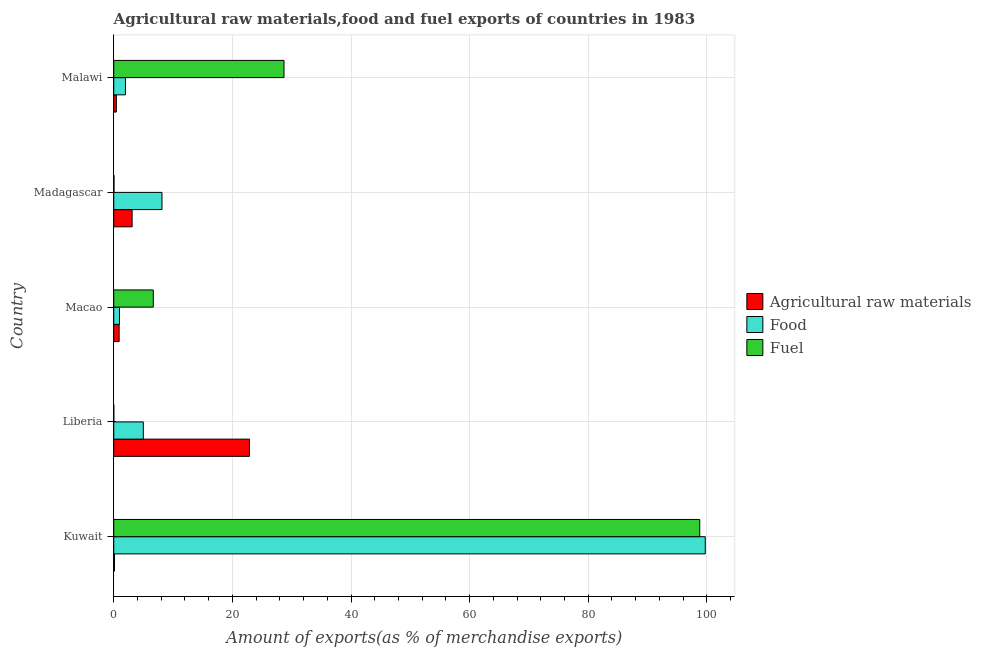How many different coloured bars are there?
Provide a succinct answer. 3. Are the number of bars on each tick of the Y-axis equal?
Offer a very short reply. Yes. What is the label of the 1st group of bars from the top?
Provide a short and direct response. Malawi. In how many cases, is the number of bars for a given country not equal to the number of legend labels?
Your answer should be compact. 0. What is the percentage of fuel exports in Kuwait?
Your response must be concise. 98.8. Across all countries, what is the maximum percentage of food exports?
Keep it short and to the point. 99.73. Across all countries, what is the minimum percentage of food exports?
Ensure brevity in your answer.  0.96. In which country was the percentage of raw materials exports maximum?
Make the answer very short. Liberia. In which country was the percentage of raw materials exports minimum?
Make the answer very short. Kuwait. What is the total percentage of fuel exports in the graph?
Provide a succinct answer. 134.22. What is the difference between the percentage of fuel exports in Madagascar and that in Malawi?
Make the answer very short. -28.67. What is the difference between the percentage of fuel exports in Macao and the percentage of food exports in Malawi?
Your answer should be very brief. 4.69. What is the average percentage of fuel exports per country?
Provide a short and direct response. 26.84. What is the difference between the percentage of food exports and percentage of raw materials exports in Madagascar?
Offer a very short reply. 5.03. What is the ratio of the percentage of food exports in Macao to that in Madagascar?
Give a very brief answer. 0.12. Is the percentage of food exports in Kuwait less than that in Malawi?
Provide a succinct answer. No. What is the difference between the highest and the second highest percentage of fuel exports?
Make the answer very short. 70.09. What is the difference between the highest and the lowest percentage of food exports?
Provide a succinct answer. 98.76. Is the sum of the percentage of food exports in Kuwait and Malawi greater than the maximum percentage of raw materials exports across all countries?
Provide a short and direct response. Yes. What does the 2nd bar from the top in Kuwait represents?
Keep it short and to the point. Food. What does the 2nd bar from the bottom in Madagascar represents?
Your answer should be very brief. Food. Is it the case that in every country, the sum of the percentage of raw materials exports and percentage of food exports is greater than the percentage of fuel exports?
Your answer should be very brief. No. How many bars are there?
Make the answer very short. 15. What is the difference between two consecutive major ticks on the X-axis?
Make the answer very short. 20. Does the graph contain grids?
Your response must be concise. Yes. Where does the legend appear in the graph?
Make the answer very short. Center right. How many legend labels are there?
Ensure brevity in your answer.  3. How are the legend labels stacked?
Your answer should be very brief. Vertical. What is the title of the graph?
Ensure brevity in your answer.  Agricultural raw materials,food and fuel exports of countries in 1983. Does "Tertiary education" appear as one of the legend labels in the graph?
Your answer should be very brief. No. What is the label or title of the X-axis?
Offer a terse response. Amount of exports(as % of merchandise exports). What is the label or title of the Y-axis?
Make the answer very short. Country. What is the Amount of exports(as % of merchandise exports) in Agricultural raw materials in Kuwait?
Provide a succinct answer. 0.13. What is the Amount of exports(as % of merchandise exports) in Food in Kuwait?
Provide a succinct answer. 99.73. What is the Amount of exports(as % of merchandise exports) in Fuel in Kuwait?
Make the answer very short. 98.8. What is the Amount of exports(as % of merchandise exports) in Agricultural raw materials in Liberia?
Make the answer very short. 22.88. What is the Amount of exports(as % of merchandise exports) in Food in Liberia?
Offer a very short reply. 4.99. What is the Amount of exports(as % of merchandise exports) in Fuel in Liberia?
Ensure brevity in your answer.  0.01. What is the Amount of exports(as % of merchandise exports) of Agricultural raw materials in Macao?
Keep it short and to the point. 0.91. What is the Amount of exports(as % of merchandise exports) of Food in Macao?
Provide a short and direct response. 0.96. What is the Amount of exports(as % of merchandise exports) in Fuel in Macao?
Make the answer very short. 6.67. What is the Amount of exports(as % of merchandise exports) of Agricultural raw materials in Madagascar?
Your answer should be very brief. 3.1. What is the Amount of exports(as % of merchandise exports) in Food in Madagascar?
Offer a very short reply. 8.13. What is the Amount of exports(as % of merchandise exports) in Fuel in Madagascar?
Your answer should be very brief. 0.04. What is the Amount of exports(as % of merchandise exports) in Agricultural raw materials in Malawi?
Your answer should be compact. 0.44. What is the Amount of exports(as % of merchandise exports) of Food in Malawi?
Make the answer very short. 1.97. What is the Amount of exports(as % of merchandise exports) in Fuel in Malawi?
Keep it short and to the point. 28.71. Across all countries, what is the maximum Amount of exports(as % of merchandise exports) in Agricultural raw materials?
Your answer should be very brief. 22.88. Across all countries, what is the maximum Amount of exports(as % of merchandise exports) in Food?
Provide a short and direct response. 99.73. Across all countries, what is the maximum Amount of exports(as % of merchandise exports) of Fuel?
Your answer should be very brief. 98.8. Across all countries, what is the minimum Amount of exports(as % of merchandise exports) in Agricultural raw materials?
Give a very brief answer. 0.13. Across all countries, what is the minimum Amount of exports(as % of merchandise exports) of Food?
Ensure brevity in your answer.  0.96. Across all countries, what is the minimum Amount of exports(as % of merchandise exports) in Fuel?
Your answer should be compact. 0.01. What is the total Amount of exports(as % of merchandise exports) in Agricultural raw materials in the graph?
Offer a very short reply. 27.45. What is the total Amount of exports(as % of merchandise exports) in Food in the graph?
Ensure brevity in your answer.  115.79. What is the total Amount of exports(as % of merchandise exports) of Fuel in the graph?
Offer a terse response. 134.22. What is the difference between the Amount of exports(as % of merchandise exports) in Agricultural raw materials in Kuwait and that in Liberia?
Your answer should be very brief. -22.75. What is the difference between the Amount of exports(as % of merchandise exports) in Food in Kuwait and that in Liberia?
Your response must be concise. 94.74. What is the difference between the Amount of exports(as % of merchandise exports) in Fuel in Kuwait and that in Liberia?
Provide a short and direct response. 98.79. What is the difference between the Amount of exports(as % of merchandise exports) in Agricultural raw materials in Kuwait and that in Macao?
Provide a short and direct response. -0.78. What is the difference between the Amount of exports(as % of merchandise exports) in Food in Kuwait and that in Macao?
Your answer should be compact. 98.76. What is the difference between the Amount of exports(as % of merchandise exports) in Fuel in Kuwait and that in Macao?
Offer a terse response. 92.13. What is the difference between the Amount of exports(as % of merchandise exports) in Agricultural raw materials in Kuwait and that in Madagascar?
Your response must be concise. -2.97. What is the difference between the Amount of exports(as % of merchandise exports) of Food in Kuwait and that in Madagascar?
Provide a succinct answer. 91.59. What is the difference between the Amount of exports(as % of merchandise exports) of Fuel in Kuwait and that in Madagascar?
Your answer should be very brief. 98.76. What is the difference between the Amount of exports(as % of merchandise exports) of Agricultural raw materials in Kuwait and that in Malawi?
Your answer should be compact. -0.32. What is the difference between the Amount of exports(as % of merchandise exports) of Food in Kuwait and that in Malawi?
Offer a terse response. 97.75. What is the difference between the Amount of exports(as % of merchandise exports) in Fuel in Kuwait and that in Malawi?
Your answer should be compact. 70.09. What is the difference between the Amount of exports(as % of merchandise exports) of Agricultural raw materials in Liberia and that in Macao?
Provide a short and direct response. 21.97. What is the difference between the Amount of exports(as % of merchandise exports) of Food in Liberia and that in Macao?
Provide a succinct answer. 4.02. What is the difference between the Amount of exports(as % of merchandise exports) of Fuel in Liberia and that in Macao?
Provide a short and direct response. -6.66. What is the difference between the Amount of exports(as % of merchandise exports) in Agricultural raw materials in Liberia and that in Madagascar?
Give a very brief answer. 19.78. What is the difference between the Amount of exports(as % of merchandise exports) of Food in Liberia and that in Madagascar?
Keep it short and to the point. -3.14. What is the difference between the Amount of exports(as % of merchandise exports) of Fuel in Liberia and that in Madagascar?
Your answer should be compact. -0.03. What is the difference between the Amount of exports(as % of merchandise exports) of Agricultural raw materials in Liberia and that in Malawi?
Provide a short and direct response. 22.44. What is the difference between the Amount of exports(as % of merchandise exports) in Food in Liberia and that in Malawi?
Provide a short and direct response. 3.01. What is the difference between the Amount of exports(as % of merchandise exports) in Fuel in Liberia and that in Malawi?
Your response must be concise. -28.7. What is the difference between the Amount of exports(as % of merchandise exports) of Agricultural raw materials in Macao and that in Madagascar?
Keep it short and to the point. -2.19. What is the difference between the Amount of exports(as % of merchandise exports) in Food in Macao and that in Madagascar?
Give a very brief answer. -7.17. What is the difference between the Amount of exports(as % of merchandise exports) in Fuel in Macao and that in Madagascar?
Your answer should be compact. 6.63. What is the difference between the Amount of exports(as % of merchandise exports) of Agricultural raw materials in Macao and that in Malawi?
Provide a short and direct response. 0.47. What is the difference between the Amount of exports(as % of merchandise exports) in Food in Macao and that in Malawi?
Offer a very short reply. -1.01. What is the difference between the Amount of exports(as % of merchandise exports) of Fuel in Macao and that in Malawi?
Ensure brevity in your answer.  -22.04. What is the difference between the Amount of exports(as % of merchandise exports) in Agricultural raw materials in Madagascar and that in Malawi?
Offer a terse response. 2.66. What is the difference between the Amount of exports(as % of merchandise exports) in Food in Madagascar and that in Malawi?
Your answer should be compact. 6.16. What is the difference between the Amount of exports(as % of merchandise exports) in Fuel in Madagascar and that in Malawi?
Your answer should be compact. -28.67. What is the difference between the Amount of exports(as % of merchandise exports) in Agricultural raw materials in Kuwait and the Amount of exports(as % of merchandise exports) in Food in Liberia?
Provide a short and direct response. -4.86. What is the difference between the Amount of exports(as % of merchandise exports) of Agricultural raw materials in Kuwait and the Amount of exports(as % of merchandise exports) of Fuel in Liberia?
Ensure brevity in your answer.  0.12. What is the difference between the Amount of exports(as % of merchandise exports) in Food in Kuwait and the Amount of exports(as % of merchandise exports) in Fuel in Liberia?
Offer a terse response. 99.72. What is the difference between the Amount of exports(as % of merchandise exports) in Agricultural raw materials in Kuwait and the Amount of exports(as % of merchandise exports) in Food in Macao?
Provide a short and direct response. -0.84. What is the difference between the Amount of exports(as % of merchandise exports) in Agricultural raw materials in Kuwait and the Amount of exports(as % of merchandise exports) in Fuel in Macao?
Give a very brief answer. -6.54. What is the difference between the Amount of exports(as % of merchandise exports) in Food in Kuwait and the Amount of exports(as % of merchandise exports) in Fuel in Macao?
Provide a succinct answer. 93.06. What is the difference between the Amount of exports(as % of merchandise exports) in Agricultural raw materials in Kuwait and the Amount of exports(as % of merchandise exports) in Food in Madagascar?
Provide a succinct answer. -8.01. What is the difference between the Amount of exports(as % of merchandise exports) of Agricultural raw materials in Kuwait and the Amount of exports(as % of merchandise exports) of Fuel in Madagascar?
Ensure brevity in your answer.  0.09. What is the difference between the Amount of exports(as % of merchandise exports) of Food in Kuwait and the Amount of exports(as % of merchandise exports) of Fuel in Madagascar?
Make the answer very short. 99.69. What is the difference between the Amount of exports(as % of merchandise exports) of Agricultural raw materials in Kuwait and the Amount of exports(as % of merchandise exports) of Food in Malawi?
Your answer should be very brief. -1.85. What is the difference between the Amount of exports(as % of merchandise exports) in Agricultural raw materials in Kuwait and the Amount of exports(as % of merchandise exports) in Fuel in Malawi?
Your answer should be compact. -28.58. What is the difference between the Amount of exports(as % of merchandise exports) of Food in Kuwait and the Amount of exports(as % of merchandise exports) of Fuel in Malawi?
Keep it short and to the point. 71.02. What is the difference between the Amount of exports(as % of merchandise exports) of Agricultural raw materials in Liberia and the Amount of exports(as % of merchandise exports) of Food in Macao?
Provide a succinct answer. 21.91. What is the difference between the Amount of exports(as % of merchandise exports) in Agricultural raw materials in Liberia and the Amount of exports(as % of merchandise exports) in Fuel in Macao?
Offer a terse response. 16.21. What is the difference between the Amount of exports(as % of merchandise exports) of Food in Liberia and the Amount of exports(as % of merchandise exports) of Fuel in Macao?
Give a very brief answer. -1.68. What is the difference between the Amount of exports(as % of merchandise exports) in Agricultural raw materials in Liberia and the Amount of exports(as % of merchandise exports) in Food in Madagascar?
Provide a short and direct response. 14.75. What is the difference between the Amount of exports(as % of merchandise exports) in Agricultural raw materials in Liberia and the Amount of exports(as % of merchandise exports) in Fuel in Madagascar?
Ensure brevity in your answer.  22.84. What is the difference between the Amount of exports(as % of merchandise exports) in Food in Liberia and the Amount of exports(as % of merchandise exports) in Fuel in Madagascar?
Your response must be concise. 4.95. What is the difference between the Amount of exports(as % of merchandise exports) of Agricultural raw materials in Liberia and the Amount of exports(as % of merchandise exports) of Food in Malawi?
Give a very brief answer. 20.9. What is the difference between the Amount of exports(as % of merchandise exports) of Agricultural raw materials in Liberia and the Amount of exports(as % of merchandise exports) of Fuel in Malawi?
Make the answer very short. -5.83. What is the difference between the Amount of exports(as % of merchandise exports) in Food in Liberia and the Amount of exports(as % of merchandise exports) in Fuel in Malawi?
Your answer should be very brief. -23.72. What is the difference between the Amount of exports(as % of merchandise exports) in Agricultural raw materials in Macao and the Amount of exports(as % of merchandise exports) in Food in Madagascar?
Your answer should be compact. -7.22. What is the difference between the Amount of exports(as % of merchandise exports) of Agricultural raw materials in Macao and the Amount of exports(as % of merchandise exports) of Fuel in Madagascar?
Provide a succinct answer. 0.87. What is the difference between the Amount of exports(as % of merchandise exports) in Food in Macao and the Amount of exports(as % of merchandise exports) in Fuel in Madagascar?
Your answer should be compact. 0.92. What is the difference between the Amount of exports(as % of merchandise exports) in Agricultural raw materials in Macao and the Amount of exports(as % of merchandise exports) in Food in Malawi?
Give a very brief answer. -1.07. What is the difference between the Amount of exports(as % of merchandise exports) in Agricultural raw materials in Macao and the Amount of exports(as % of merchandise exports) in Fuel in Malawi?
Your answer should be compact. -27.8. What is the difference between the Amount of exports(as % of merchandise exports) in Food in Macao and the Amount of exports(as % of merchandise exports) in Fuel in Malawi?
Keep it short and to the point. -27.74. What is the difference between the Amount of exports(as % of merchandise exports) in Agricultural raw materials in Madagascar and the Amount of exports(as % of merchandise exports) in Food in Malawi?
Your answer should be compact. 1.12. What is the difference between the Amount of exports(as % of merchandise exports) in Agricultural raw materials in Madagascar and the Amount of exports(as % of merchandise exports) in Fuel in Malawi?
Offer a terse response. -25.61. What is the difference between the Amount of exports(as % of merchandise exports) of Food in Madagascar and the Amount of exports(as % of merchandise exports) of Fuel in Malawi?
Your answer should be very brief. -20.57. What is the average Amount of exports(as % of merchandise exports) of Agricultural raw materials per country?
Your answer should be very brief. 5.49. What is the average Amount of exports(as % of merchandise exports) in Food per country?
Ensure brevity in your answer.  23.16. What is the average Amount of exports(as % of merchandise exports) of Fuel per country?
Give a very brief answer. 26.84. What is the difference between the Amount of exports(as % of merchandise exports) of Agricultural raw materials and Amount of exports(as % of merchandise exports) of Food in Kuwait?
Provide a succinct answer. -99.6. What is the difference between the Amount of exports(as % of merchandise exports) of Agricultural raw materials and Amount of exports(as % of merchandise exports) of Fuel in Kuwait?
Provide a succinct answer. -98.67. What is the difference between the Amount of exports(as % of merchandise exports) in Food and Amount of exports(as % of merchandise exports) in Fuel in Kuwait?
Give a very brief answer. 0.93. What is the difference between the Amount of exports(as % of merchandise exports) of Agricultural raw materials and Amount of exports(as % of merchandise exports) of Food in Liberia?
Your answer should be very brief. 17.89. What is the difference between the Amount of exports(as % of merchandise exports) in Agricultural raw materials and Amount of exports(as % of merchandise exports) in Fuel in Liberia?
Provide a succinct answer. 22.87. What is the difference between the Amount of exports(as % of merchandise exports) of Food and Amount of exports(as % of merchandise exports) of Fuel in Liberia?
Your answer should be compact. 4.98. What is the difference between the Amount of exports(as % of merchandise exports) of Agricultural raw materials and Amount of exports(as % of merchandise exports) of Food in Macao?
Keep it short and to the point. -0.06. What is the difference between the Amount of exports(as % of merchandise exports) in Agricultural raw materials and Amount of exports(as % of merchandise exports) in Fuel in Macao?
Make the answer very short. -5.76. What is the difference between the Amount of exports(as % of merchandise exports) of Food and Amount of exports(as % of merchandise exports) of Fuel in Macao?
Ensure brevity in your answer.  -5.7. What is the difference between the Amount of exports(as % of merchandise exports) in Agricultural raw materials and Amount of exports(as % of merchandise exports) in Food in Madagascar?
Ensure brevity in your answer.  -5.03. What is the difference between the Amount of exports(as % of merchandise exports) in Agricultural raw materials and Amount of exports(as % of merchandise exports) in Fuel in Madagascar?
Ensure brevity in your answer.  3.06. What is the difference between the Amount of exports(as % of merchandise exports) in Food and Amount of exports(as % of merchandise exports) in Fuel in Madagascar?
Your answer should be compact. 8.09. What is the difference between the Amount of exports(as % of merchandise exports) in Agricultural raw materials and Amount of exports(as % of merchandise exports) in Food in Malawi?
Provide a succinct answer. -1.53. What is the difference between the Amount of exports(as % of merchandise exports) in Agricultural raw materials and Amount of exports(as % of merchandise exports) in Fuel in Malawi?
Offer a terse response. -28.27. What is the difference between the Amount of exports(as % of merchandise exports) in Food and Amount of exports(as % of merchandise exports) in Fuel in Malawi?
Your response must be concise. -26.73. What is the ratio of the Amount of exports(as % of merchandise exports) in Agricultural raw materials in Kuwait to that in Liberia?
Your response must be concise. 0.01. What is the ratio of the Amount of exports(as % of merchandise exports) of Food in Kuwait to that in Liberia?
Keep it short and to the point. 19.99. What is the ratio of the Amount of exports(as % of merchandise exports) of Fuel in Kuwait to that in Liberia?
Your response must be concise. 1.00e+04. What is the ratio of the Amount of exports(as % of merchandise exports) of Agricultural raw materials in Kuwait to that in Macao?
Your answer should be very brief. 0.14. What is the ratio of the Amount of exports(as % of merchandise exports) in Food in Kuwait to that in Macao?
Your response must be concise. 103.41. What is the ratio of the Amount of exports(as % of merchandise exports) in Fuel in Kuwait to that in Macao?
Provide a succinct answer. 14.82. What is the ratio of the Amount of exports(as % of merchandise exports) in Agricultural raw materials in Kuwait to that in Madagascar?
Your response must be concise. 0.04. What is the ratio of the Amount of exports(as % of merchandise exports) in Food in Kuwait to that in Madagascar?
Your response must be concise. 12.26. What is the ratio of the Amount of exports(as % of merchandise exports) in Fuel in Kuwait to that in Madagascar?
Keep it short and to the point. 2455.04. What is the ratio of the Amount of exports(as % of merchandise exports) of Agricultural raw materials in Kuwait to that in Malawi?
Offer a terse response. 0.29. What is the ratio of the Amount of exports(as % of merchandise exports) in Food in Kuwait to that in Malawi?
Provide a short and direct response. 50.51. What is the ratio of the Amount of exports(as % of merchandise exports) of Fuel in Kuwait to that in Malawi?
Provide a short and direct response. 3.44. What is the ratio of the Amount of exports(as % of merchandise exports) of Agricultural raw materials in Liberia to that in Macao?
Make the answer very short. 25.16. What is the ratio of the Amount of exports(as % of merchandise exports) in Food in Liberia to that in Macao?
Give a very brief answer. 5.17. What is the ratio of the Amount of exports(as % of merchandise exports) of Fuel in Liberia to that in Macao?
Keep it short and to the point. 0. What is the ratio of the Amount of exports(as % of merchandise exports) in Agricultural raw materials in Liberia to that in Madagascar?
Offer a very short reply. 7.38. What is the ratio of the Amount of exports(as % of merchandise exports) of Food in Liberia to that in Madagascar?
Your answer should be very brief. 0.61. What is the ratio of the Amount of exports(as % of merchandise exports) in Fuel in Liberia to that in Madagascar?
Your response must be concise. 0.24. What is the ratio of the Amount of exports(as % of merchandise exports) in Agricultural raw materials in Liberia to that in Malawi?
Provide a succinct answer. 51.85. What is the ratio of the Amount of exports(as % of merchandise exports) in Food in Liberia to that in Malawi?
Provide a succinct answer. 2.53. What is the ratio of the Amount of exports(as % of merchandise exports) in Agricultural raw materials in Macao to that in Madagascar?
Ensure brevity in your answer.  0.29. What is the ratio of the Amount of exports(as % of merchandise exports) in Food in Macao to that in Madagascar?
Make the answer very short. 0.12. What is the ratio of the Amount of exports(as % of merchandise exports) of Fuel in Macao to that in Madagascar?
Keep it short and to the point. 165.66. What is the ratio of the Amount of exports(as % of merchandise exports) in Agricultural raw materials in Macao to that in Malawi?
Keep it short and to the point. 2.06. What is the ratio of the Amount of exports(as % of merchandise exports) in Food in Macao to that in Malawi?
Give a very brief answer. 0.49. What is the ratio of the Amount of exports(as % of merchandise exports) of Fuel in Macao to that in Malawi?
Provide a short and direct response. 0.23. What is the ratio of the Amount of exports(as % of merchandise exports) of Agricultural raw materials in Madagascar to that in Malawi?
Give a very brief answer. 7.02. What is the ratio of the Amount of exports(as % of merchandise exports) in Food in Madagascar to that in Malawi?
Give a very brief answer. 4.12. What is the ratio of the Amount of exports(as % of merchandise exports) in Fuel in Madagascar to that in Malawi?
Keep it short and to the point. 0. What is the difference between the highest and the second highest Amount of exports(as % of merchandise exports) of Agricultural raw materials?
Offer a terse response. 19.78. What is the difference between the highest and the second highest Amount of exports(as % of merchandise exports) of Food?
Provide a succinct answer. 91.59. What is the difference between the highest and the second highest Amount of exports(as % of merchandise exports) of Fuel?
Your answer should be compact. 70.09. What is the difference between the highest and the lowest Amount of exports(as % of merchandise exports) in Agricultural raw materials?
Offer a terse response. 22.75. What is the difference between the highest and the lowest Amount of exports(as % of merchandise exports) in Food?
Give a very brief answer. 98.76. What is the difference between the highest and the lowest Amount of exports(as % of merchandise exports) in Fuel?
Provide a succinct answer. 98.79. 